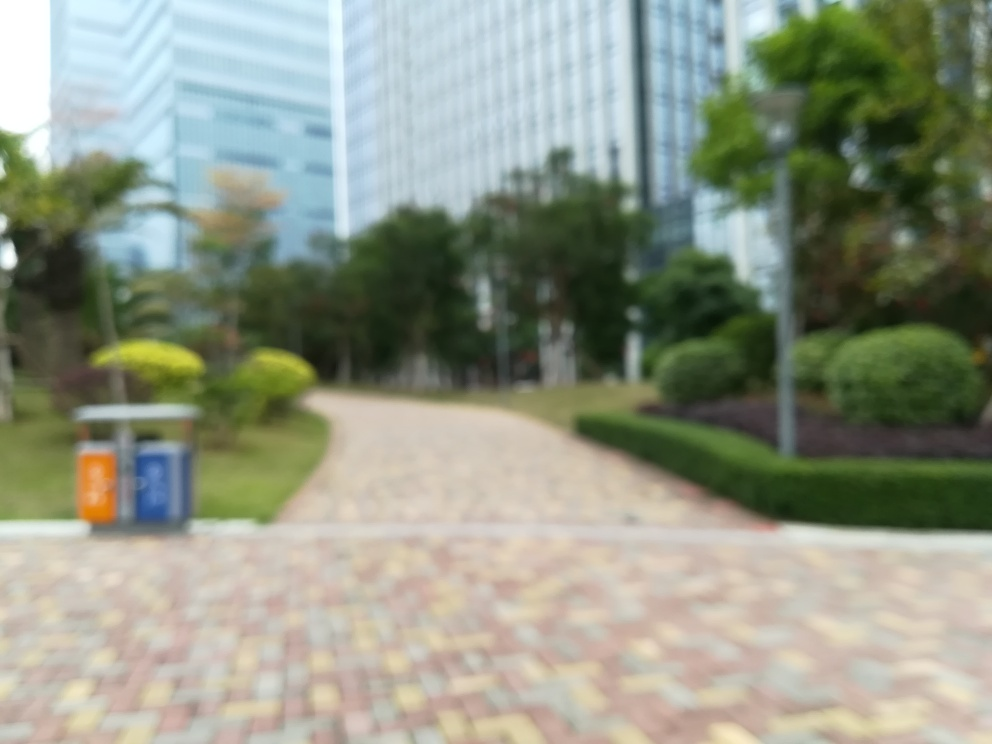What might be the cause of the blurriness in this image? The blurriness could be due to a number of factors, such as camera movement during exposure, an incorrect focus setting, or a low-quality camera lens. It also may be intentional to create an artistic effect or to obscure a specific element within the frame. 